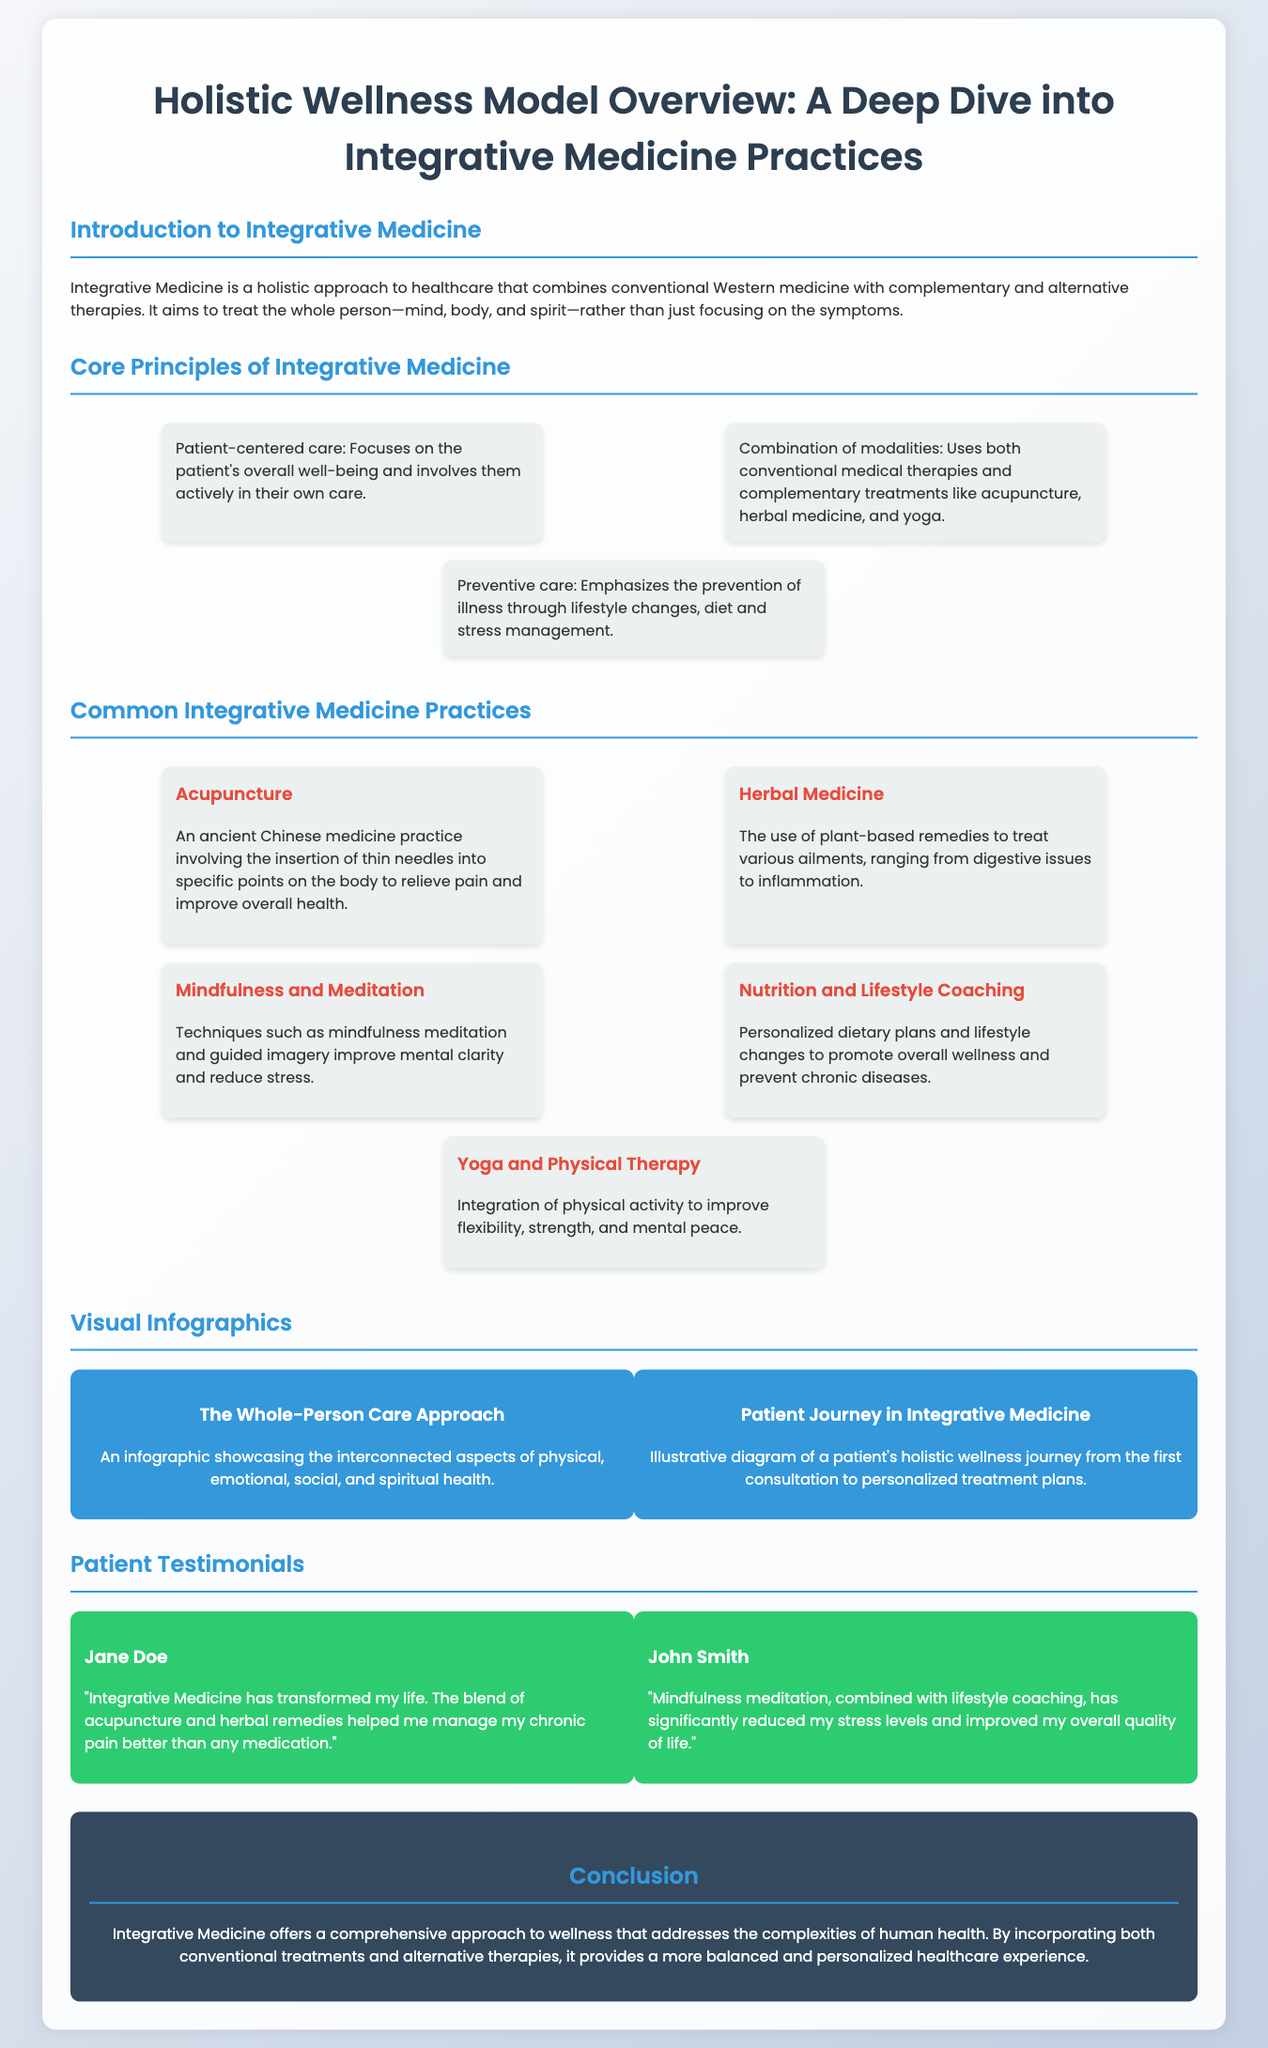What is the main focus of Integrative Medicine? Integrative Medicine focuses on treating the whole person—mind, body, and spirit—rather than just focusing on the symptoms.
Answer: whole person What is one common practice mentioned in the document? The document lists various practices, one of which is acupuncture as a common practice in Integrative Medicine.
Answer: acupuncture Who provided a testimonial about managing chronic pain? The document includes a testimonial from Jane Doe, who shares her experience with chronic pain management.
Answer: Jane Doe What does the infographic "Patient Journey in Integrative Medicine" illustrate? The infographic illustrates a patient's holistic wellness journey from the first consultation to personalized treatment plans.
Answer: patient's holistic wellness journey How many core principles of Integrative Medicine are mentioned? The document outlines three core principles of Integrative Medicine.
Answer: three What therapeutic practice involves the insertion of thin needles? Acupuncture is the practice involving the insertion of thin needles into specific points on the body.
Answer: Acupuncture What is emphasized by the principle of preventive care? Preventive care emphasizes the prevention of illness through lifestyle changes, diet, and stress management.
Answer: prevention of illness What are patients encouraged to do according to the principle of patient-centered care? Patients are encouraged to be actively involved in their own care according to the principle of patient-centered care.
Answer: actively involved 